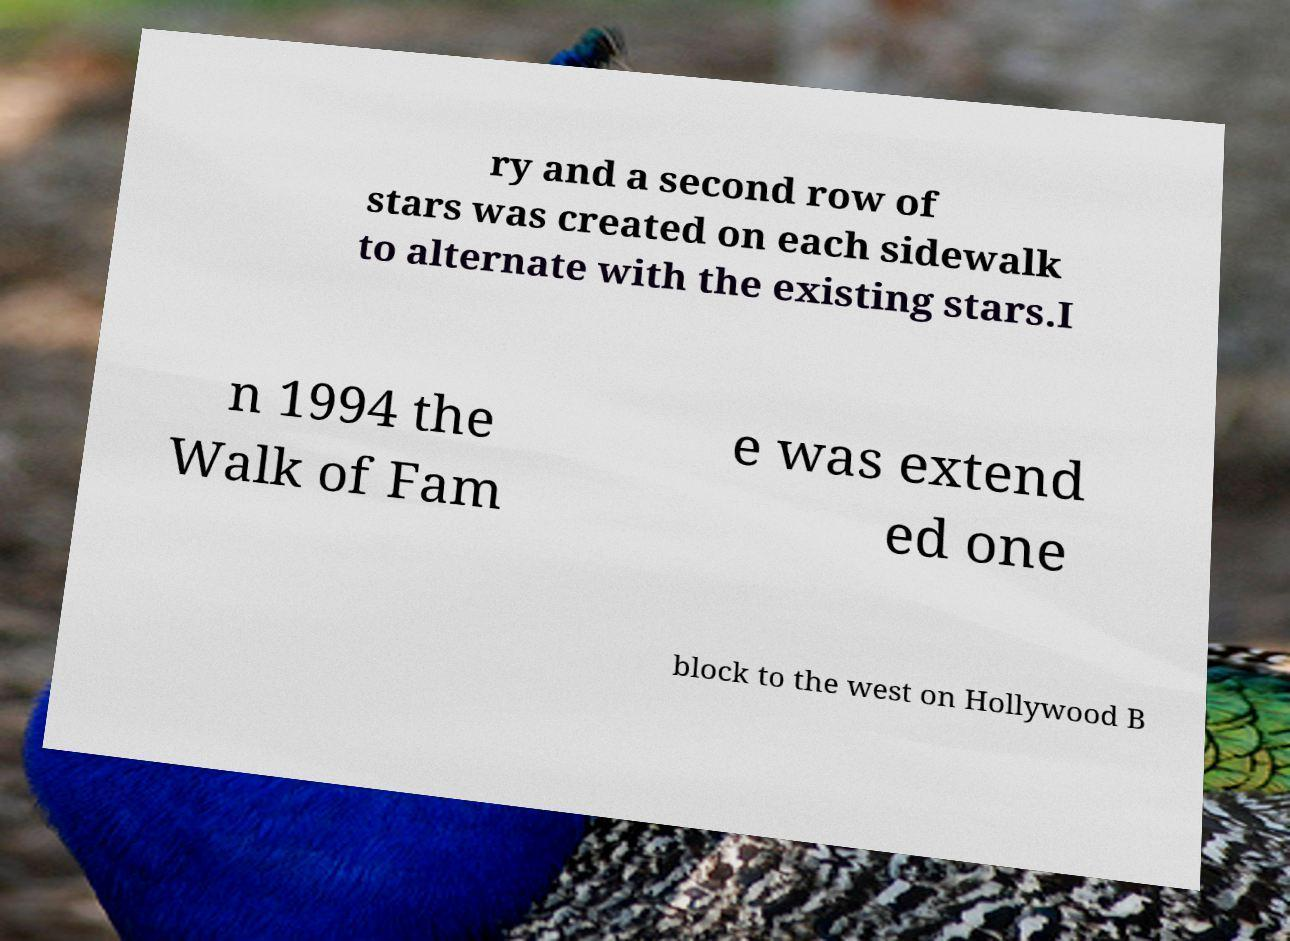I need the written content from this picture converted into text. Can you do that? ry and a second row of stars was created on each sidewalk to alternate with the existing stars.I n 1994 the Walk of Fam e was extend ed one block to the west on Hollywood B 